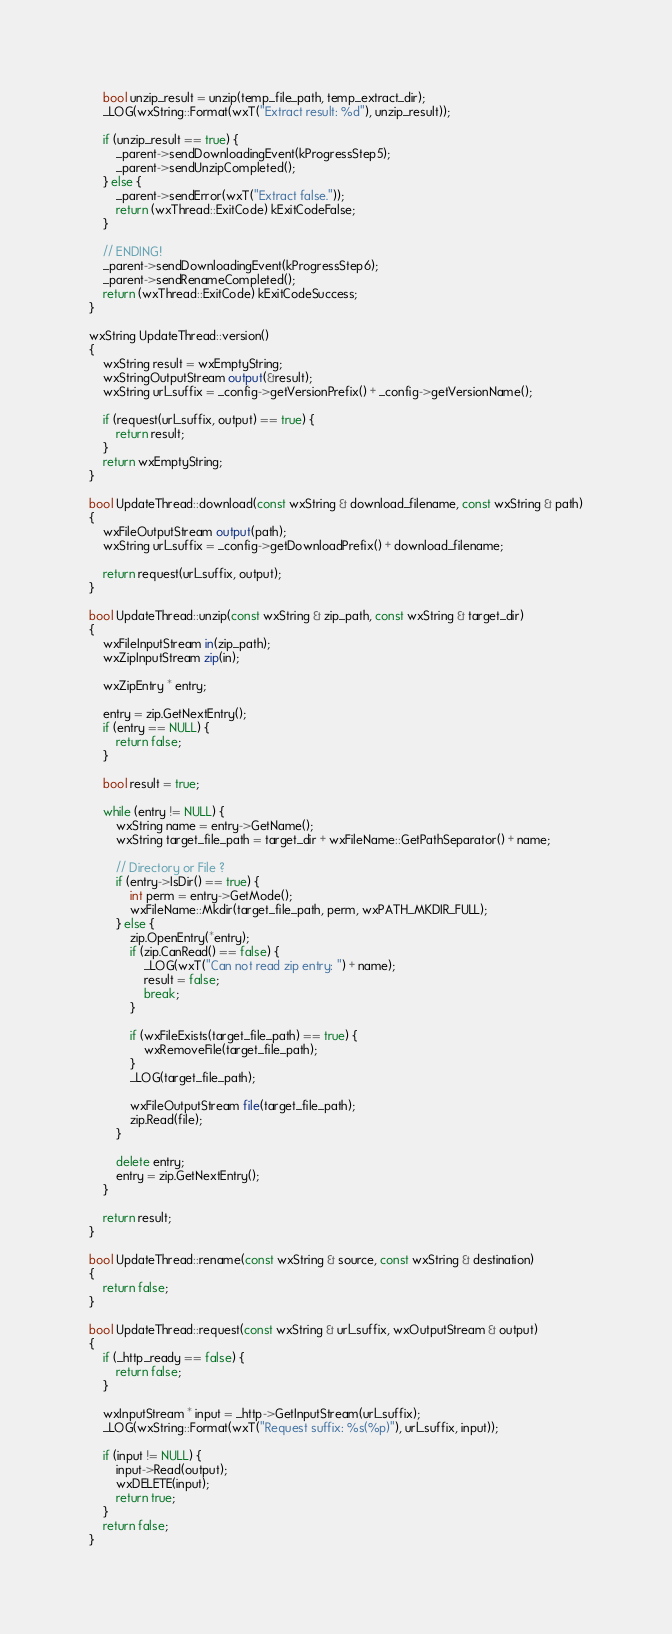<code> <loc_0><loc_0><loc_500><loc_500><_C++_>    bool unzip_result = unzip(temp_file_path, temp_extract_dir);
    _LOG(wxString::Format(wxT("Extract result: %d"), unzip_result));

    if (unzip_result == true) {
        _parent->sendDownloadingEvent(kProgressStep5);
        _parent->sendUnzipCompleted();
    } else {
        _parent->sendError(wxT("Extract false."));
        return (wxThread::ExitCode) kExitCodeFalse;
    }

    // ENDING!
    _parent->sendDownloadingEvent(kProgressStep6);
    _parent->sendRenameCompleted();
    return (wxThread::ExitCode) kExitCodeSuccess;
}

wxString UpdateThread::version()
{
    wxString result = wxEmptyString;
    wxStringOutputStream output(&result);
    wxString url_suffix = _config->getVersionPrefix() + _config->getVersionName();

    if (request(url_suffix, output) == true) {
        return result;
    }
    return wxEmptyString;
}

bool UpdateThread::download(const wxString & download_filename, const wxString & path)
{
    wxFileOutputStream output(path);
    wxString url_suffix = _config->getDownloadPrefix() + download_filename;

    return request(url_suffix, output);
}

bool UpdateThread::unzip(const wxString & zip_path, const wxString & target_dir)
{
    wxFileInputStream in(zip_path);
    wxZipInputStream zip(in);

    wxZipEntry * entry;

    entry = zip.GetNextEntry();
    if (entry == NULL) {
        return false;
    }

    bool result = true;

    while (entry != NULL) {
        wxString name = entry->GetName();
        wxString target_file_path = target_dir + wxFileName::GetPathSeparator() + name;

        // Directory or File ?
        if (entry->IsDir() == true) {
            int perm = entry->GetMode();
            wxFileName::Mkdir(target_file_path, perm, wxPATH_MKDIR_FULL);
        } else {
            zip.OpenEntry(*entry);
            if (zip.CanRead() == false) {
                _LOG(wxT("Can not read zip entry: ") + name);
                result = false;
                break;
            }

            if (wxFileExists(target_file_path) == true) {
                wxRemoveFile(target_file_path);
            }
            _LOG(target_file_path);

            wxFileOutputStream file(target_file_path);
            zip.Read(file);
        }

        delete entry;
        entry = zip.GetNextEntry();
    }

    return result;
}

bool UpdateThread::rename(const wxString & source, const wxString & destination)
{
    return false;
}

bool UpdateThread::request(const wxString & url_suffix, wxOutputStream & output)
{
    if (_http_ready == false) {
        return false;
    }

    wxInputStream * input = _http->GetInputStream(url_suffix);
    _LOG(wxString::Format(wxT("Request suffix: %s(%p)"), url_suffix, input));

    if (input != NULL) {
        input->Read(output);
        wxDELETE(input);
        return true;
    }
    return false;
}

</code> 